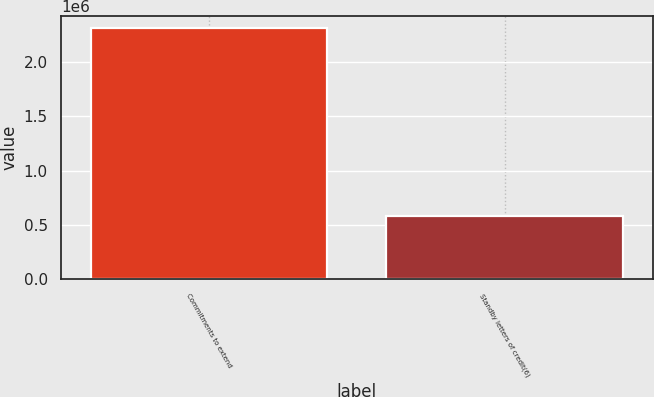Convert chart to OTSL. <chart><loc_0><loc_0><loc_500><loc_500><bar_chart><fcel>Commitments to extend<fcel>Standby letters of credit(6)<nl><fcel>2.31016e+06<fcel>580462<nl></chart> 